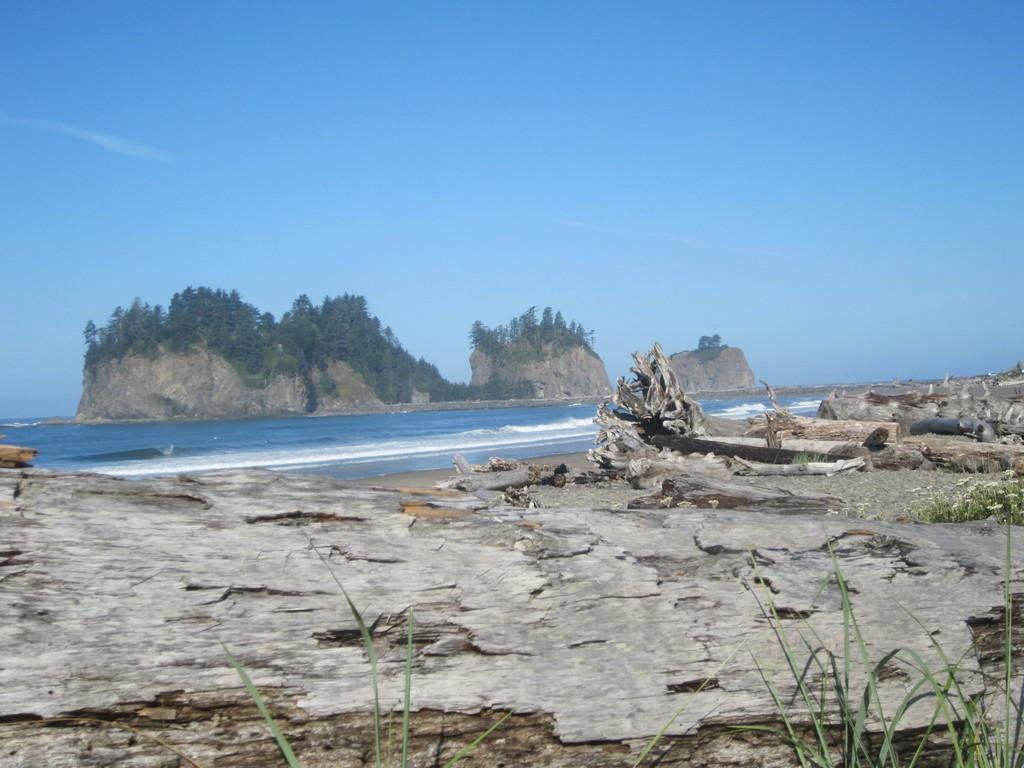What can be found in the right corner of the image? There are tree trunks in the right corner of the image. What is visible in the image besides the tree trunks? There is water visible in the image. What can be seen in the background of the image? There are mountains in the background of the image. How are the mountains covered? The mountains are covered with trees. What shape is the eye of the banana in the image? There is no banana or eye present in the image. How many bananas can be seen in the image? There are no bananas present in the image. 